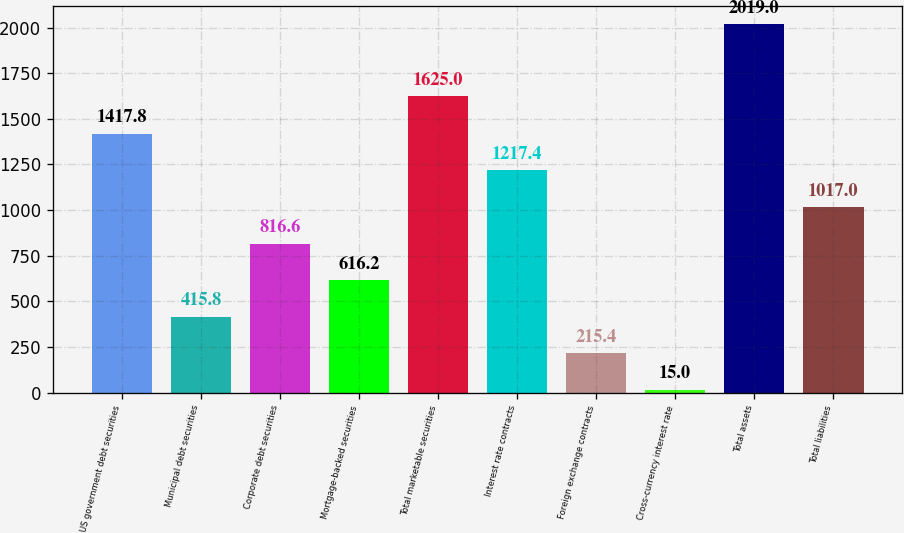<chart> <loc_0><loc_0><loc_500><loc_500><bar_chart><fcel>US government debt securities<fcel>Municipal debt securities<fcel>Corporate debt securities<fcel>Mortgage-backed securities<fcel>Total marketable securities<fcel>Interest rate contracts<fcel>Foreign exchange contracts<fcel>Cross-currency interest rate<fcel>Total assets<fcel>Total liabilities<nl><fcel>1417.8<fcel>415.8<fcel>816.6<fcel>616.2<fcel>1625<fcel>1217.4<fcel>215.4<fcel>15<fcel>2019<fcel>1017<nl></chart> 